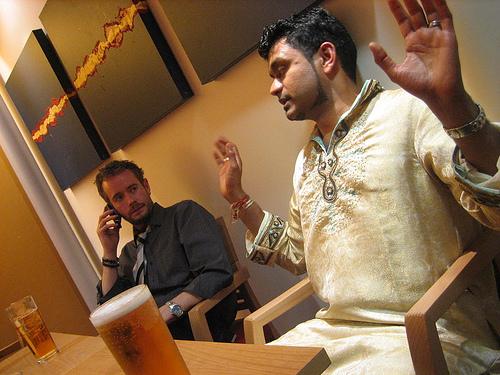Is the person with the raised hands wearing any rings?
Quick response, please. Yes. Is there a phone in the room?
Short answer required. Yes. How many people are raising hands?
Give a very brief answer. 1. 